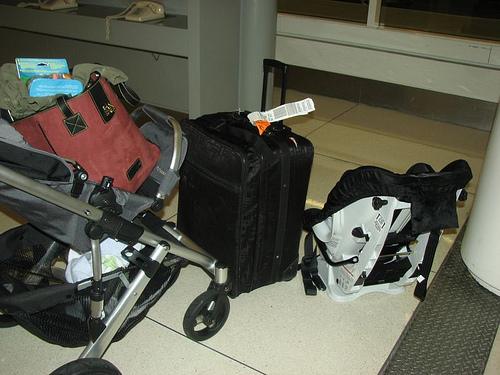What color is the  suitcase?
Quick response, please. Black. What color is the car seat cover?
Write a very short answer. Black. What is the object to the right of the suitcase?
Answer briefly. Car seat. 